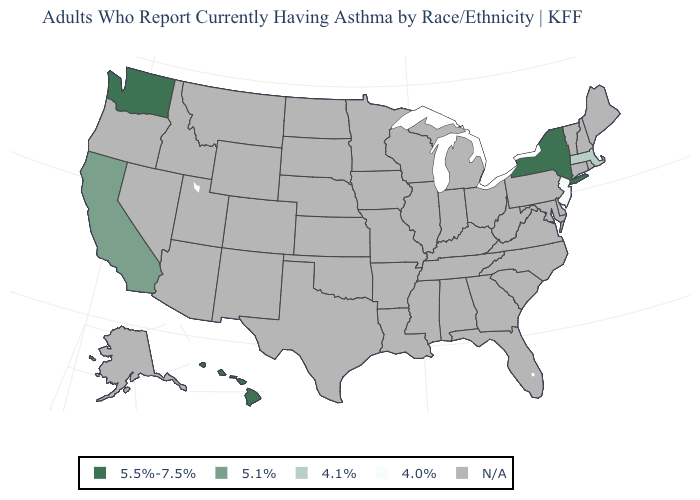Is the legend a continuous bar?
Be succinct. No. Name the states that have a value in the range 5.5%-7.5%?
Keep it brief. Hawaii, New York, Washington. How many symbols are there in the legend?
Short answer required. 5. Name the states that have a value in the range N/A?
Answer briefly. Alabama, Alaska, Arizona, Arkansas, Colorado, Connecticut, Delaware, Florida, Georgia, Idaho, Illinois, Indiana, Iowa, Kansas, Kentucky, Louisiana, Maine, Maryland, Michigan, Minnesota, Mississippi, Missouri, Montana, Nebraska, Nevada, New Hampshire, New Mexico, North Carolina, North Dakota, Ohio, Oklahoma, Oregon, Pennsylvania, Rhode Island, South Carolina, South Dakota, Tennessee, Texas, Utah, Vermont, Virginia, West Virginia, Wisconsin, Wyoming. Name the states that have a value in the range 5.1%?
Concise answer only. California. What is the value of Wisconsin?
Give a very brief answer. N/A. Name the states that have a value in the range 4.1%?
Write a very short answer. Massachusetts. Does Washington have the highest value in the West?
Be succinct. Yes. What is the value of Minnesota?
Short answer required. N/A. Does Washington have the highest value in the USA?
Short answer required. Yes. What is the lowest value in the USA?
Answer briefly. 4.0%. 